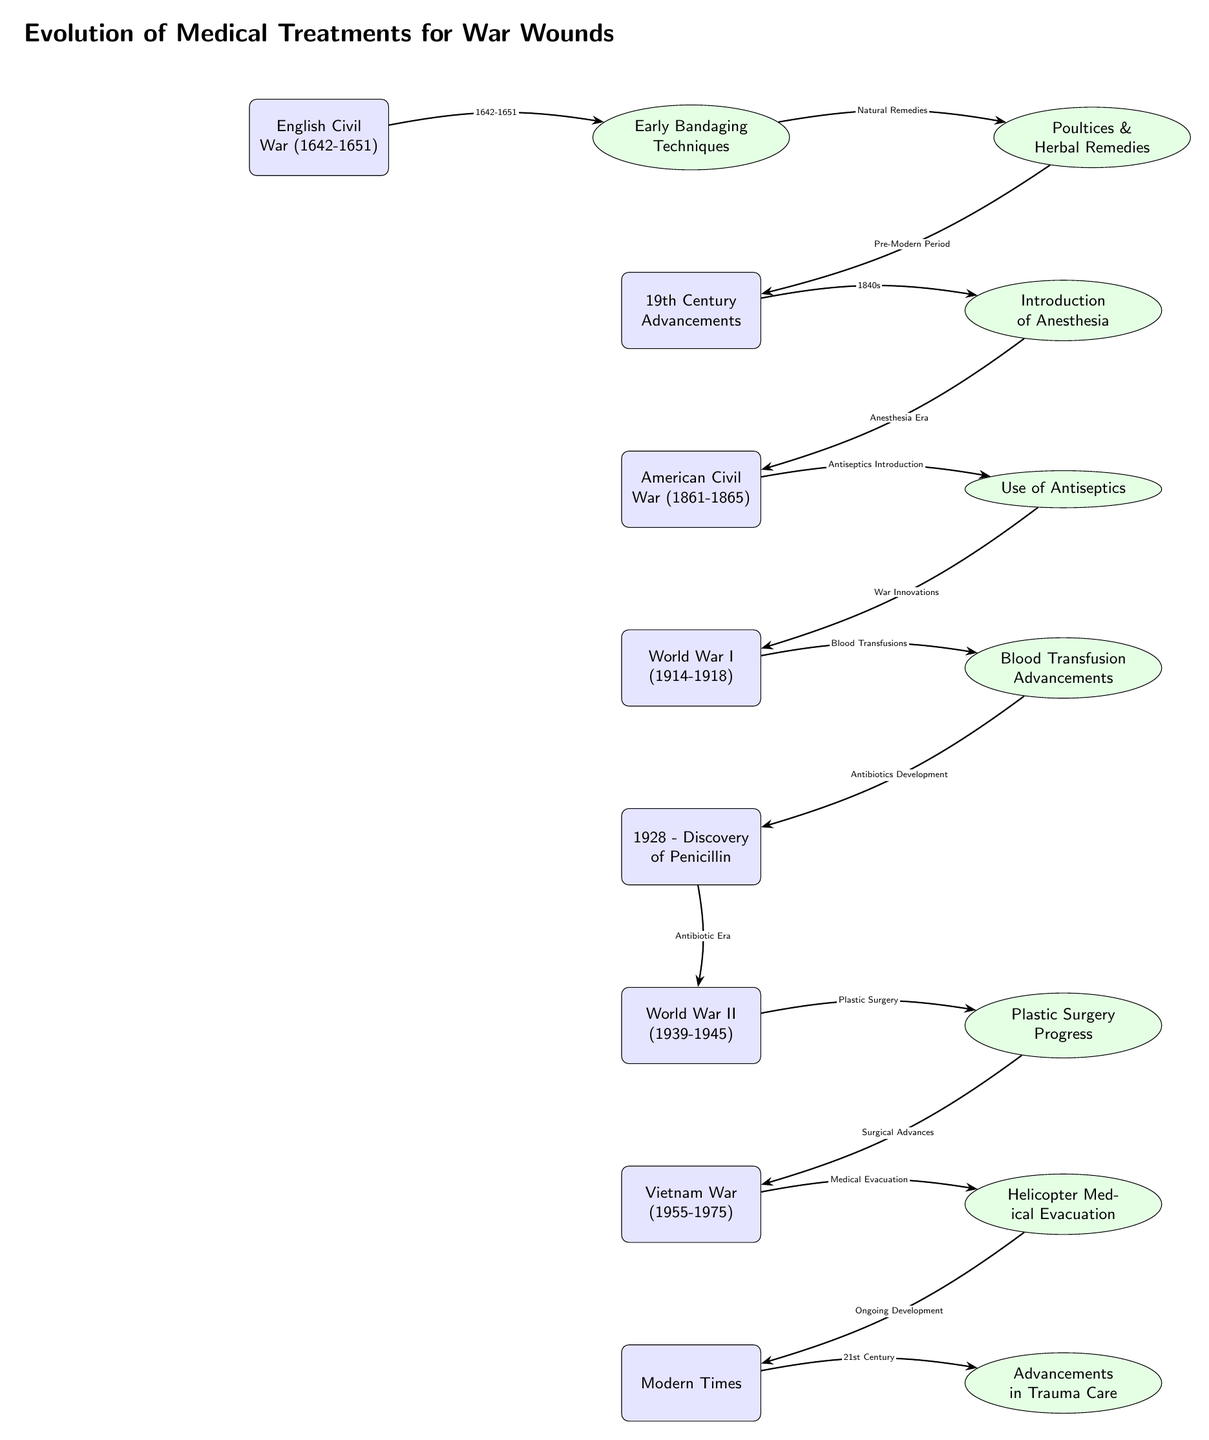What is the starting event in the timeline? The diagram begins with the event "English Civil War (1642-1651)", which is the first node mentioned in the timeline.
Answer: English Civil War (1642-1651) How many major wars are represented in the timeline? By counting the distinct events listed in the diagram, there are five major wars: English Civil War, American Civil War, World War I, World War II, and Vietnam War.
Answer: 5 Which treatment is associated with the American Civil War? The American Civil War node points to the treatment "Use of Antiseptics," indicating its significance during that period.
Answer: Use of Antiseptics What treatment was introduced during the 19th Century advancements? The treatment introduced in this node is "Introduction of Anesthesia," which is prominently associated with improvements made in the 19th Century.
Answer: Introduction of Anesthesia What is the connection between the use of antiseptics and blood transfusion advancements? The flow from the "Use of Antiseptics" node leads directly to the "Blood Transfusion Advancements," highlighting that antiseptics were part of a larger innovation in medical practices during the war periods.
Answer: Use of Antiseptics → Blood Transfusion Advancements How do advancements in trauma care relate to medical evacuation in the Vietnam War? The "Helicopter Medical Evacuation" during the Vietnam War directly leads to "Advancements in Trauma Care," suggesting that improvements made in evacuation methods influenced trauma care practices subsequently.
Answer: Helicopter Medical Evacuation → Advancements in Trauma Care What development occurred in 1928? The arrow leading from the event section specifies "1928 - Discovery of Penicillin," marking an important milestone in medical treatments during that time.
Answer: Discovery of Penicillin What treatment follows the introduction of plastic surgery in World War II? Following the "Plastic Surgery Progress" node, the diagram indicates "Vietnam War (1955-1975)" which relates the advancements in surgical techniques to ongoing developments in medical treatments.
Answer: Vietnam War (1955-1975) What major development is associated with modern times? The timeline culminates in "Advancements in Trauma Care," indicating the current progress in medical treatments for war wounds as a result of historical innovations.
Answer: Advancements in Trauma Care 